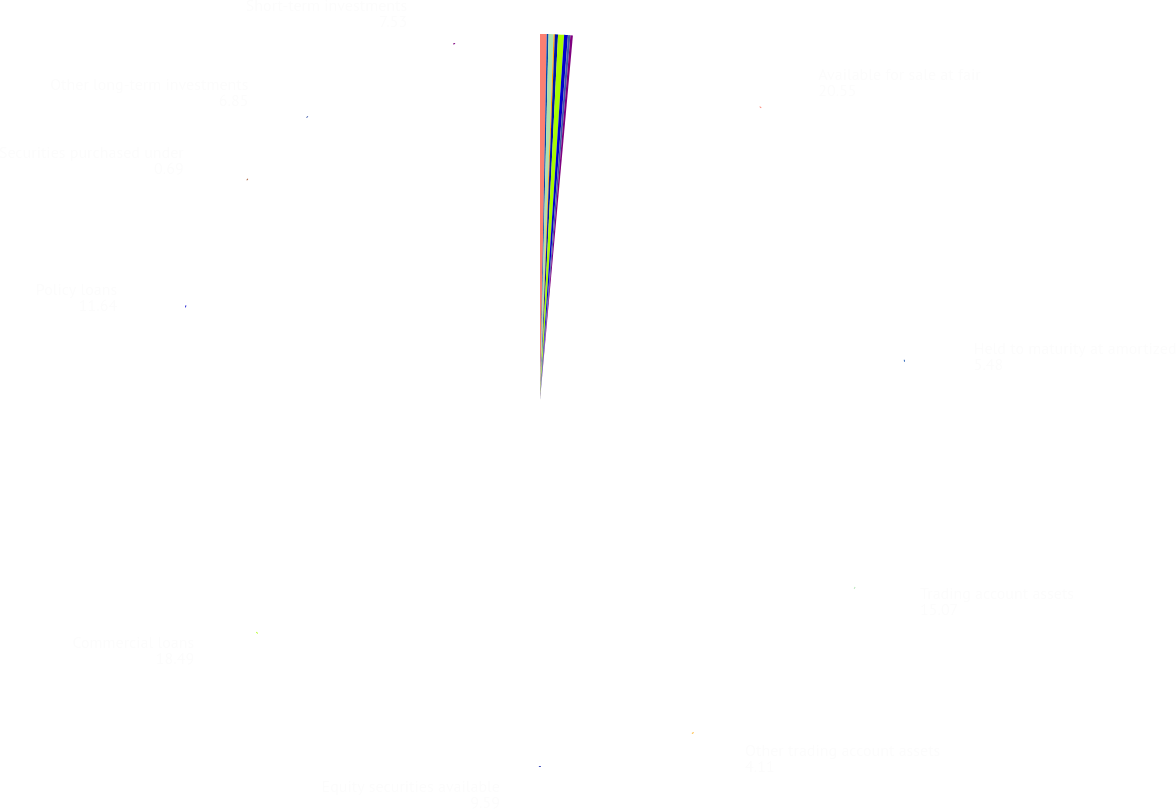Convert chart to OTSL. <chart><loc_0><loc_0><loc_500><loc_500><pie_chart><fcel>Available for sale at fair<fcel>Held to maturity at amortized<fcel>Trading account assets<fcel>Other trading account assets<fcel>Equity securities available<fcel>Commercial loans<fcel>Policy loans<fcel>Securities purchased under<fcel>Other long-term investments<fcel>Short-term investments<nl><fcel>20.55%<fcel>5.48%<fcel>15.07%<fcel>4.11%<fcel>9.59%<fcel>18.49%<fcel>11.64%<fcel>0.69%<fcel>6.85%<fcel>7.53%<nl></chart> 